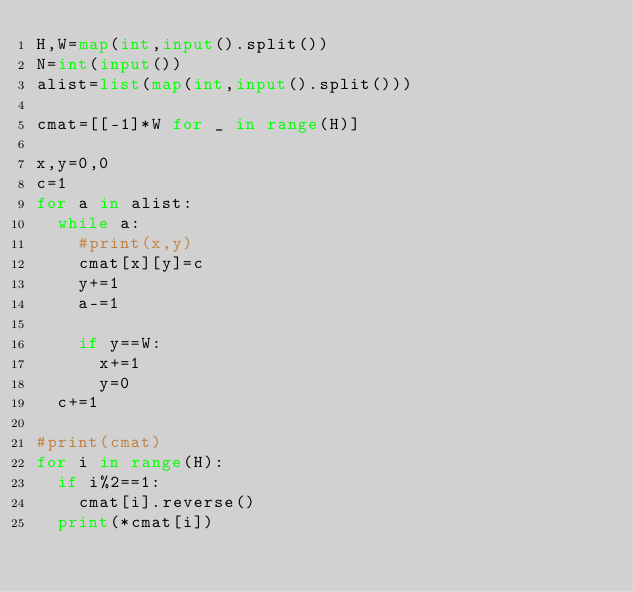Convert code to text. <code><loc_0><loc_0><loc_500><loc_500><_Python_>H,W=map(int,input().split())
N=int(input())
alist=list(map(int,input().split()))

cmat=[[-1]*W for _ in range(H)]

x,y=0,0
c=1
for a in alist:
  while a:
    #print(x,y)
    cmat[x][y]=c
    y+=1
    a-=1
    
    if y==W:
      x+=1
      y=0
  c+=1
      
#print(cmat)
for i in range(H):
  if i%2==1:
    cmat[i].reverse()
  print(*cmat[i])</code> 